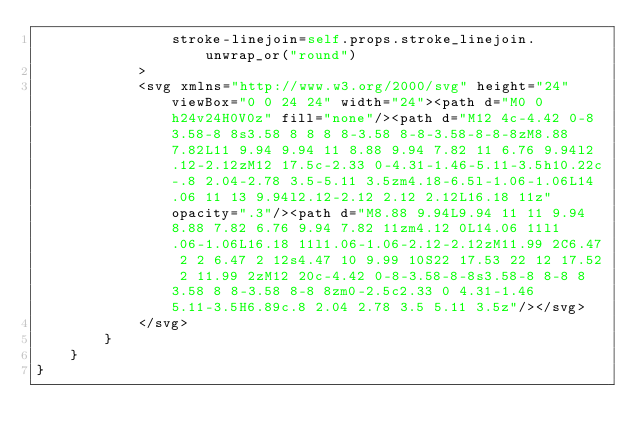Convert code to text. <code><loc_0><loc_0><loc_500><loc_500><_Rust_>                stroke-linejoin=self.props.stroke_linejoin.unwrap_or("round")
            >
            <svg xmlns="http://www.w3.org/2000/svg" height="24" viewBox="0 0 24 24" width="24"><path d="M0 0h24v24H0V0z" fill="none"/><path d="M12 4c-4.42 0-8 3.58-8 8s3.58 8 8 8 8-3.58 8-8-3.58-8-8-8zM8.88 7.82L11 9.94 9.94 11 8.88 9.94 7.82 11 6.76 9.94l2.12-2.12zM12 17.5c-2.33 0-4.31-1.46-5.11-3.5h10.22c-.8 2.04-2.78 3.5-5.11 3.5zm4.18-6.5l-1.06-1.06L14.06 11 13 9.94l2.12-2.12 2.12 2.12L16.18 11z" opacity=".3"/><path d="M8.88 9.94L9.94 11 11 9.94 8.88 7.82 6.76 9.94 7.82 11zm4.12 0L14.06 11l1.06-1.06L16.18 11l1.06-1.06-2.12-2.12zM11.99 2C6.47 2 2 6.47 2 12s4.47 10 9.99 10S22 17.53 22 12 17.52 2 11.99 2zM12 20c-4.42 0-8-3.58-8-8s3.58-8 8-8 8 3.58 8 8-3.58 8-8 8zm0-2.5c2.33 0 4.31-1.46 5.11-3.5H6.89c.8 2.04 2.78 3.5 5.11 3.5z"/></svg>
            </svg>
        }
    }
}


</code> 